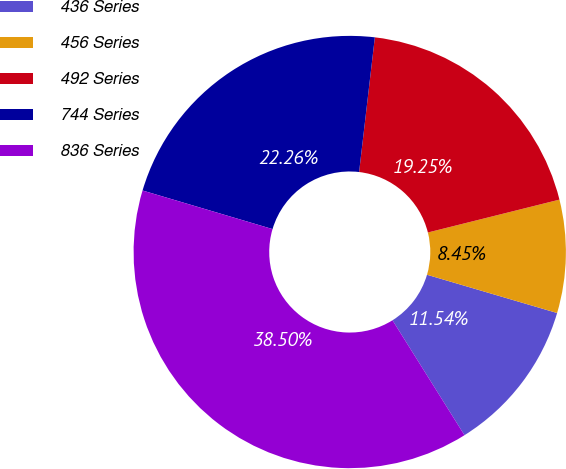Convert chart. <chart><loc_0><loc_0><loc_500><loc_500><pie_chart><fcel>436 Series<fcel>456 Series<fcel>492 Series<fcel>744 Series<fcel>836 Series<nl><fcel>11.54%<fcel>8.45%<fcel>19.25%<fcel>22.26%<fcel>38.5%<nl></chart> 